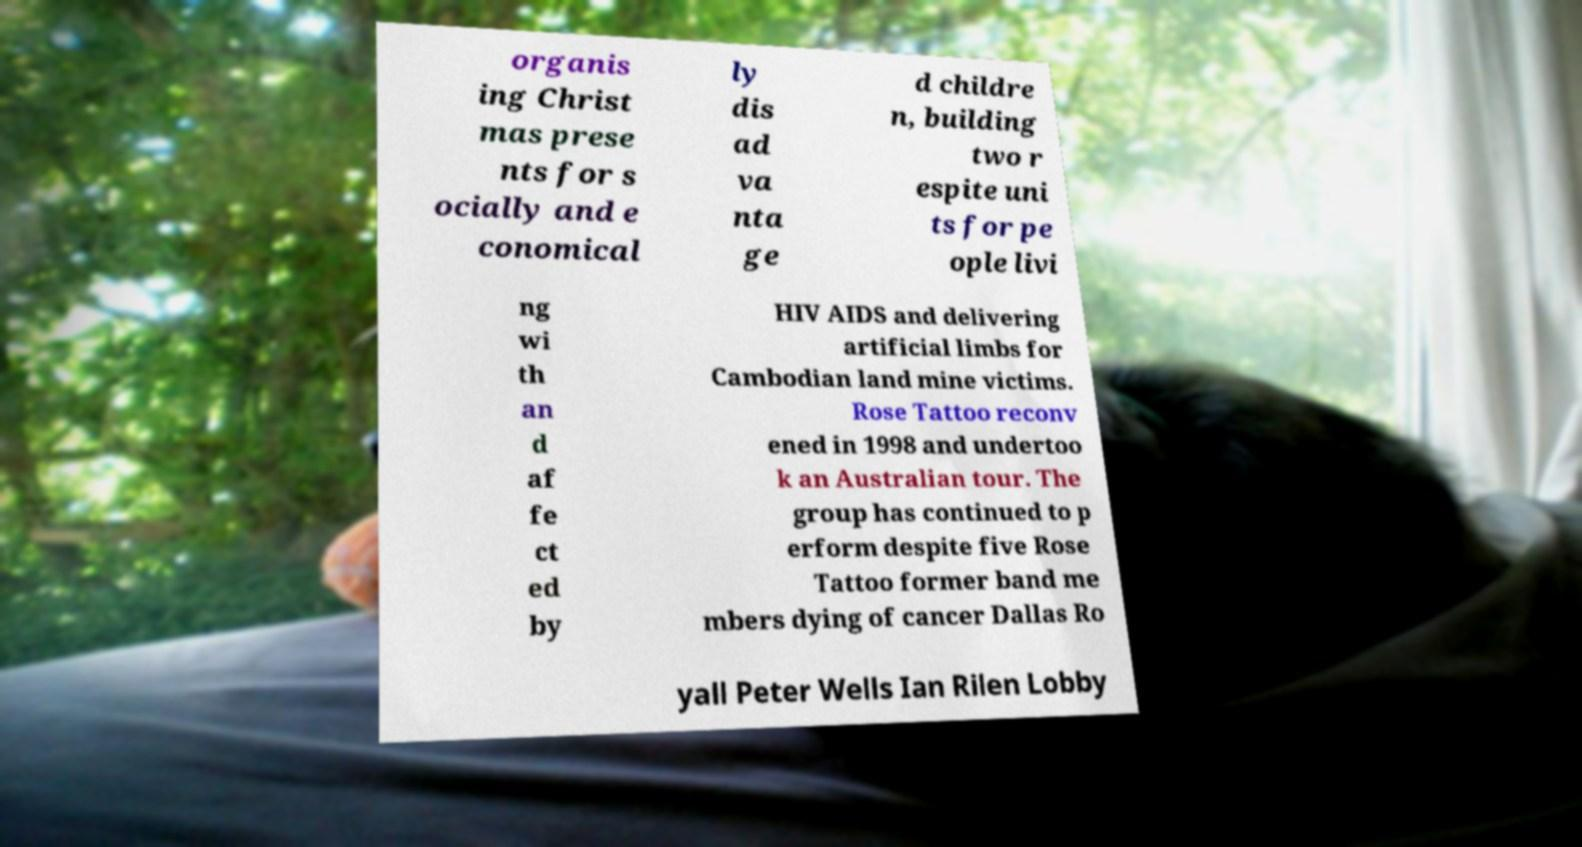Please identify and transcribe the text found in this image. organis ing Christ mas prese nts for s ocially and e conomical ly dis ad va nta ge d childre n, building two r espite uni ts for pe ople livi ng wi th an d af fe ct ed by HIV AIDS and delivering artificial limbs for Cambodian land mine victims. Rose Tattoo reconv ened in 1998 and undertoo k an Australian tour. The group has continued to p erform despite five Rose Tattoo former band me mbers dying of cancer Dallas Ro yall Peter Wells Ian Rilen Lobby 